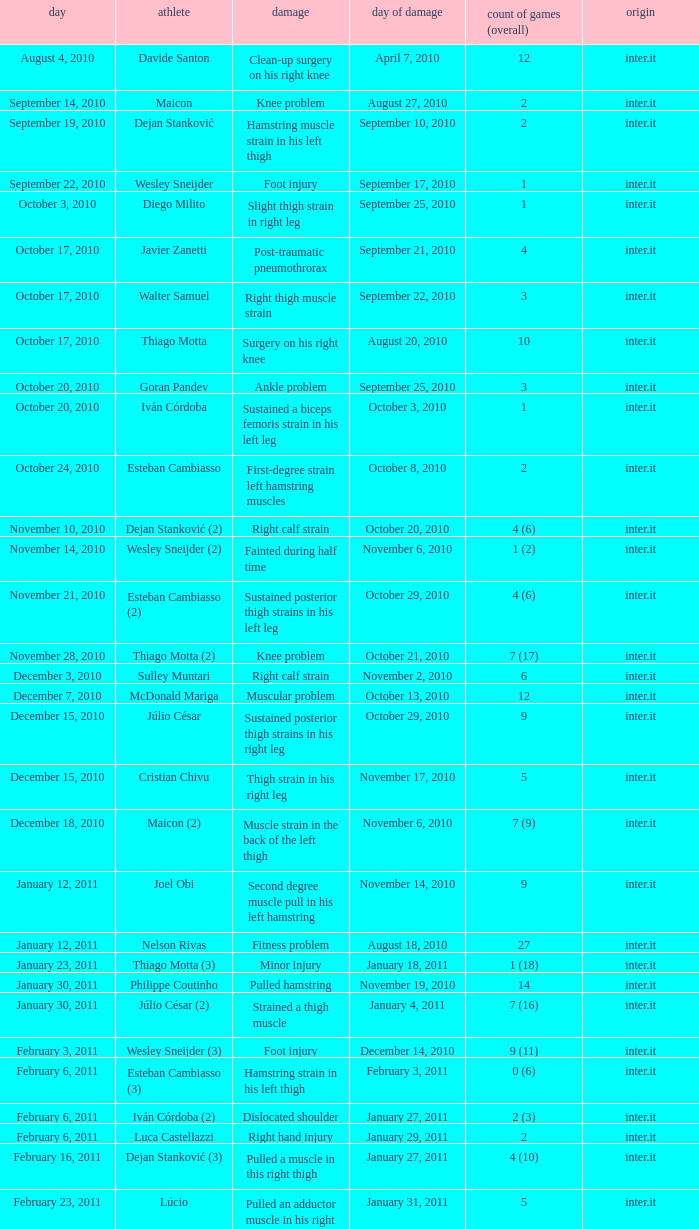What is the date of injury when the injury is foot injury and the number of matches (total) is 1? September 17, 2010. 